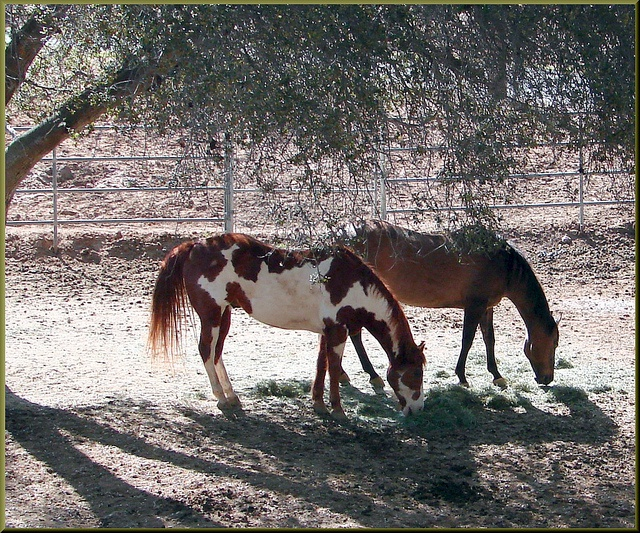Describe the objects in this image and their specific colors. I can see horse in olive, black, gray, and maroon tones and horse in olive, black, maroon, gray, and lightgray tones in this image. 